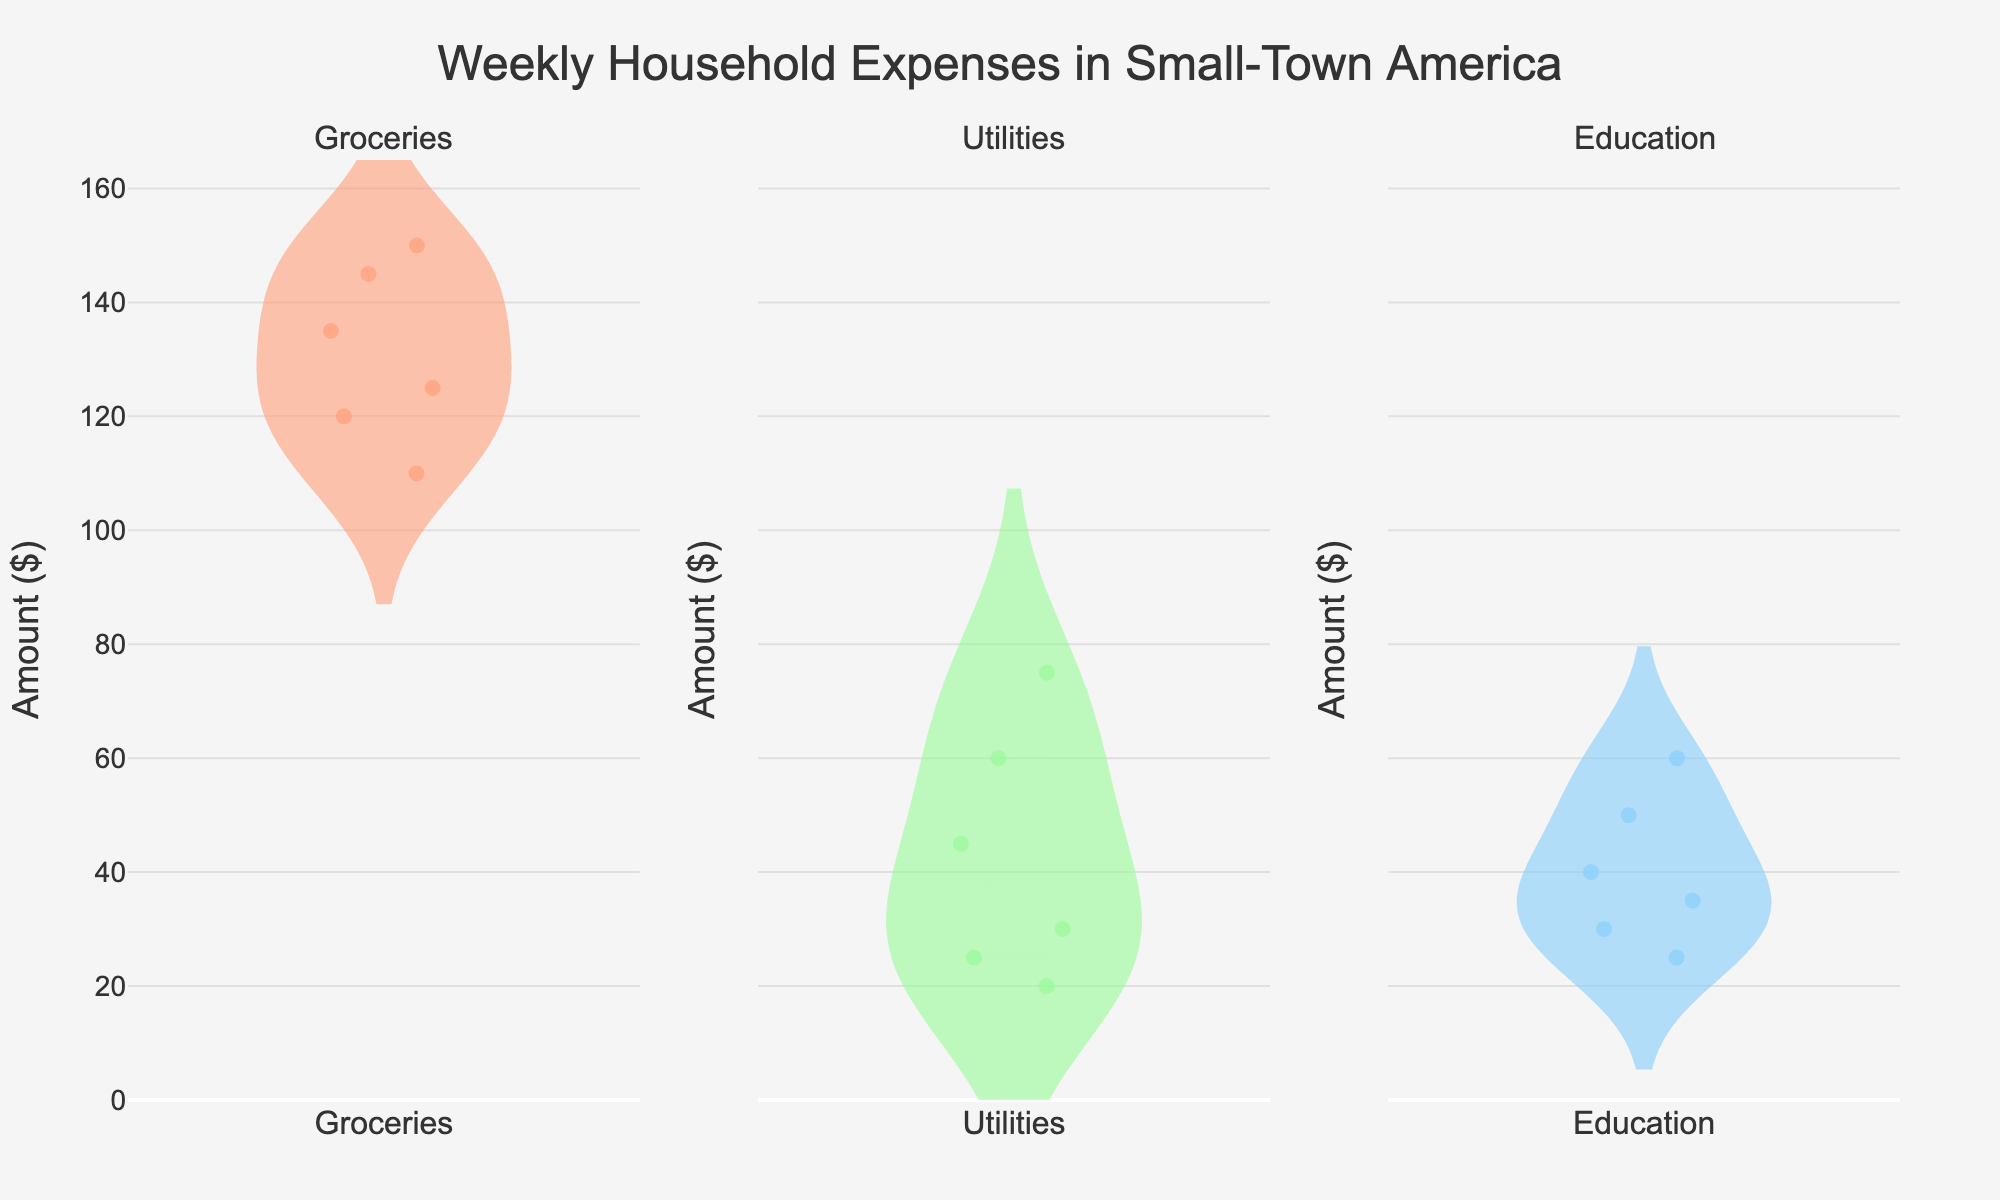What's the title of the chart? The title of the chart is typically displayed at the top of the figure. In this case, it reads 'Weekly Household Expenses in Small-Town America'.
Answer: Weekly Household Expenses in Small-Town America What's the highest expense in the Groceries category? To find the highest expense, look at the topmost point in the violin plot for the Groceries category. The highest value shown is $150 from FoodMart.
Answer: $150 Which Utilities expense has the lowest amount? Identify the lowest point in the Utilities category's violin plot. The lowest value shown is $20 from SewerService.
Answer: SewerService What is the median value for Education expenses? The median value is represented by the middle line in the box plot within the violin plot for the Education category. It is approximately $37.50.
Answer: $37.50 How does the average Groceries expense compare to the average Utilities expense? Calculate the average of all amounts in the Groceries category and compare it to the average of all amounts in the Utilities category. Groceries: (150 + 120 + 135 + 110 + 145 + 125)/6 = 131.67. Utilities: (60 + 30 + 45 + 75 + 25 + 20)/6 = 42.50. Therefore, the average Groceries expense is significantly higher than the average Utilities expense.
Answer: Groceries are higher Which category shows the widest spread of data points? The spread of data points can be observed by the width of the violin plots. The Groceries category shows a wider spread, indicating a wider range of expenses.
Answer: Groceries What's the difference between the maximum and minimum expenses in the Utilities category? The maximum value in Utilities is $75 (CableInternet) and the minimum is $20 (SewerService). Difference = 75 - 20 = $55.
Answer: $55 How many points are shown for the Groceries category? Count the number of jittered points in the Groceries category's plot. There are 6 points.
Answer: 6 In which category does the highest observed value fall? Compare the highest values observed in each category. The highest overall value is $150 in the Groceries category.
Answer: Groceries What is the mean value of the expenses in the Education category? The mean value is calculated by summing all the expenses in the Education category and dividing by the number of points. Education: (30 + 50 + 40 + 25 + 60 + 35)/6 = 40.
Answer: 40 